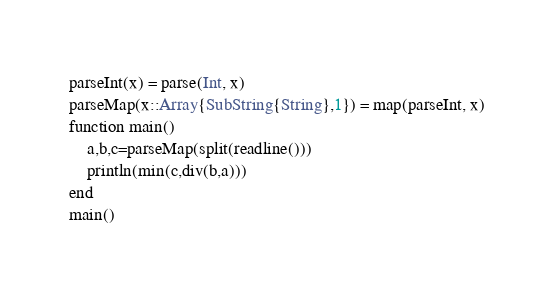<code> <loc_0><loc_0><loc_500><loc_500><_Julia_>parseInt(x) = parse(Int, x)
parseMap(x::Array{SubString{String},1}) = map(parseInt, x)
function main()
    a,b,c=parseMap(split(readline()))
    println(min(c,div(b,a)))
end
main()</code> 